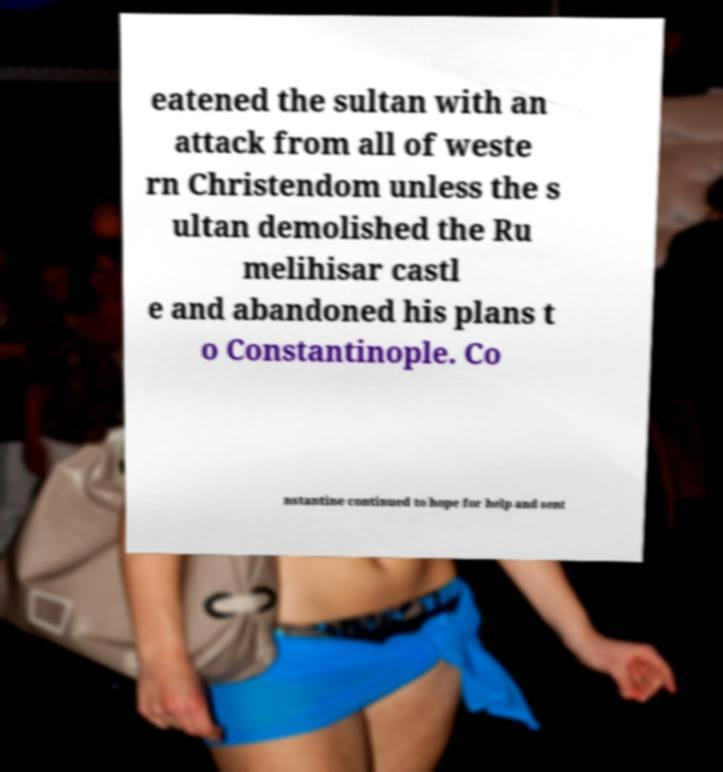Could you assist in decoding the text presented in this image and type it out clearly? eatened the sultan with an attack from all of weste rn Christendom unless the s ultan demolished the Ru melihisar castl e and abandoned his plans t o Constantinople. Co nstantine continued to hope for help and sent 